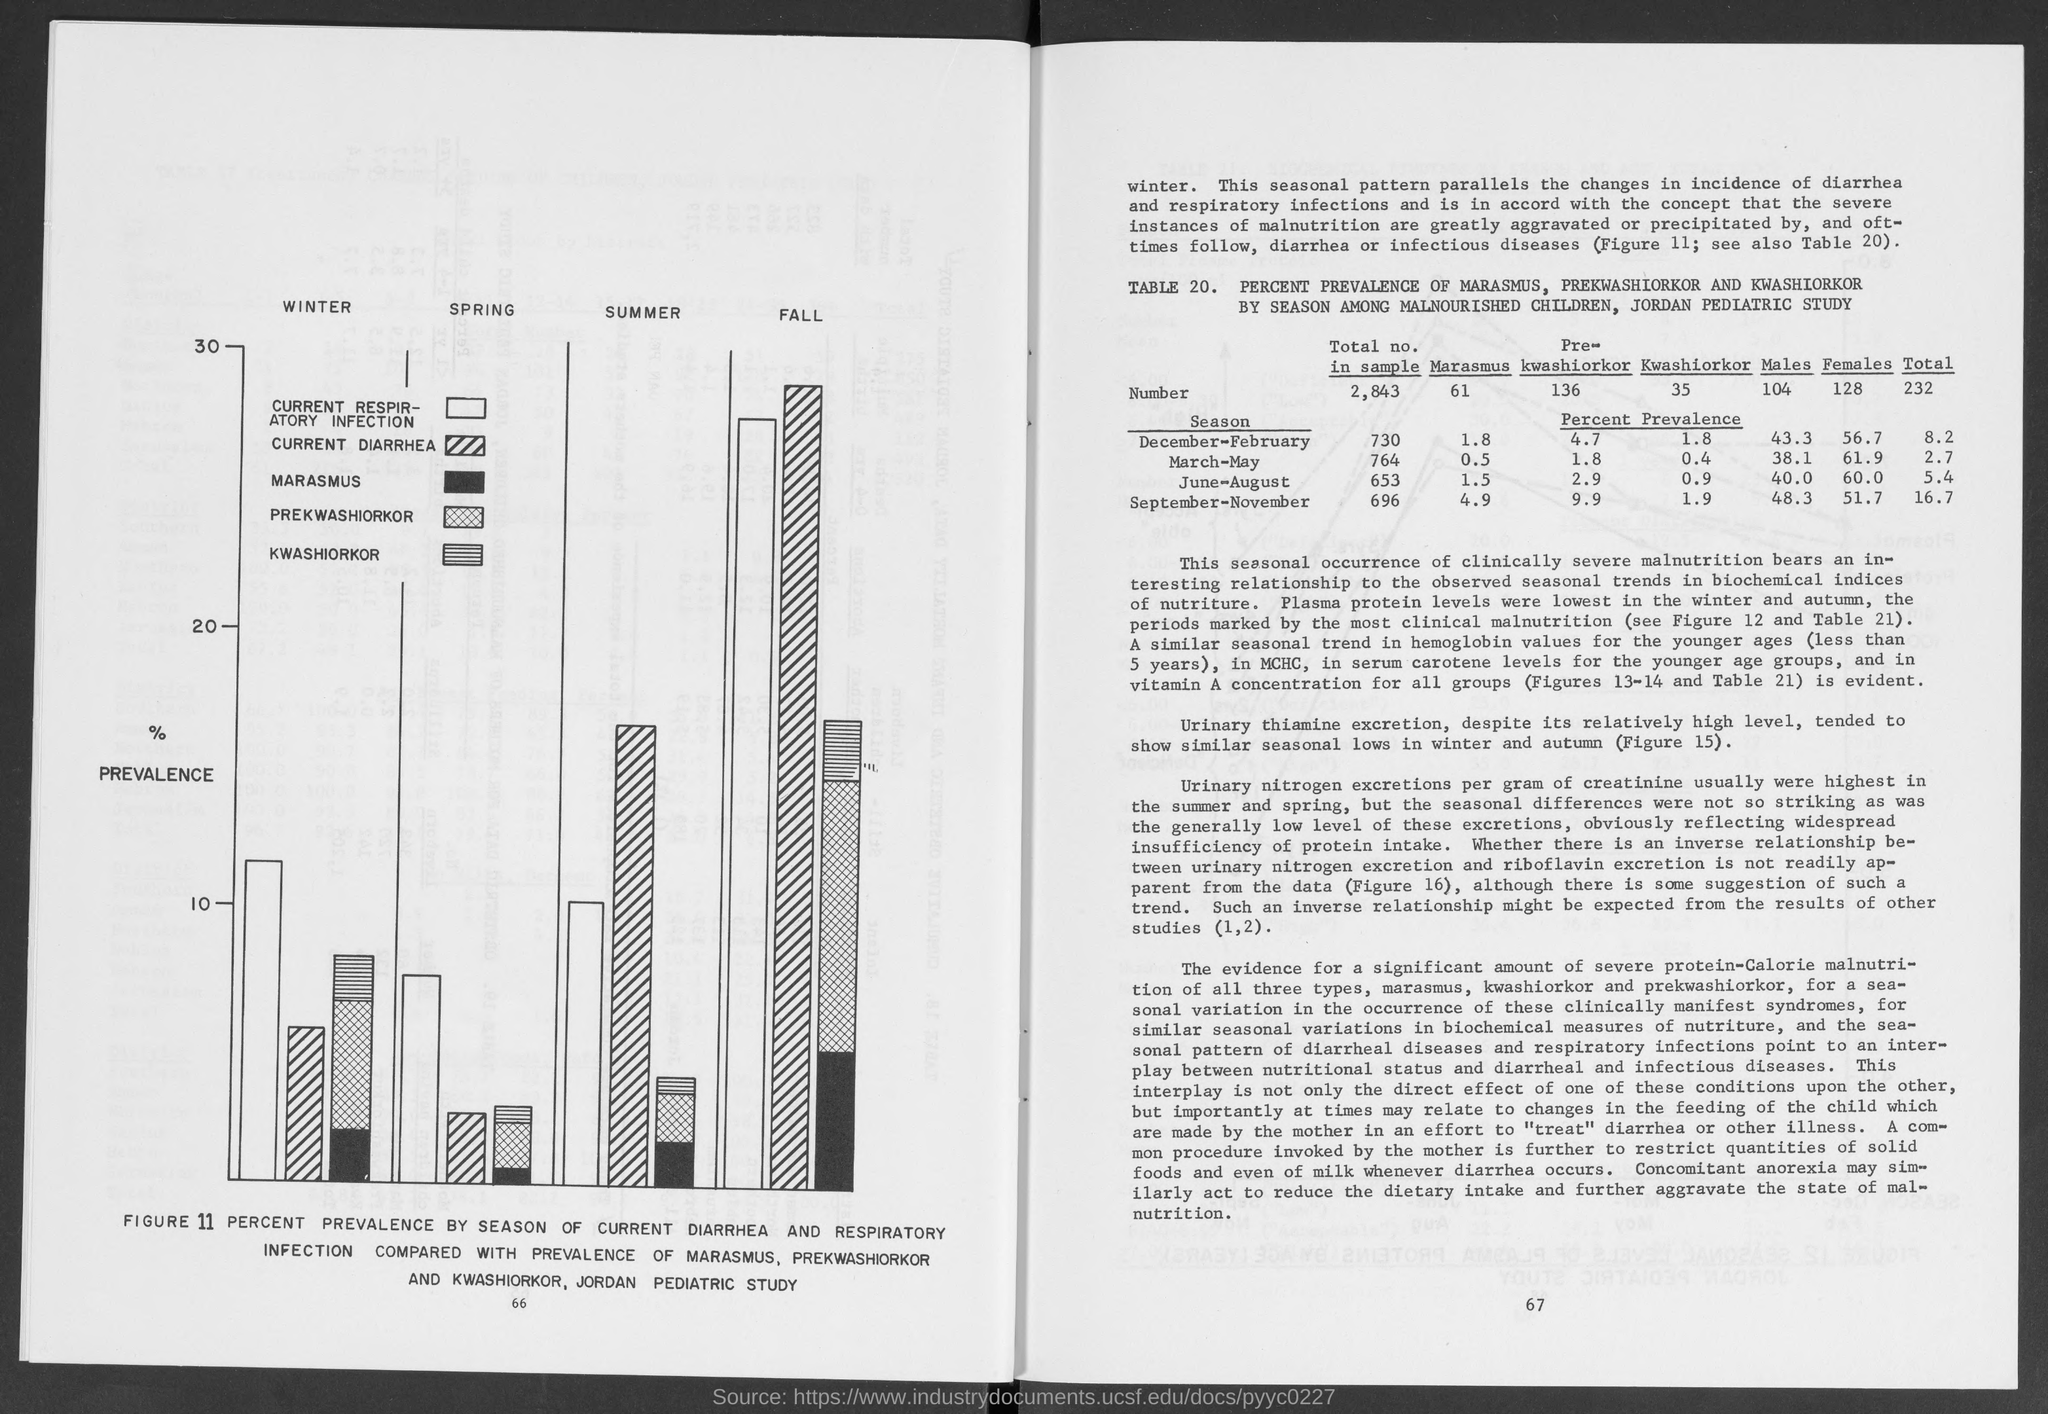What is on the y-axis of the  graph?
Give a very brief answer. % PREVALENCE. "Plasma protein levels were lowest" in which period"?
Ensure brevity in your answer.  Winter and Autumn. What was the"total no. in sample"?
Your response must be concise. 2,843. What was the"Total no. in Marasmus"?
Give a very brief answer. 61. What was the"Total no. in Kwashiorkar"?
Your answer should be very brief. 35. What is the "Percent Prevalence" of "Marasmus"  in "December-February" season?
Ensure brevity in your answer.  1.8. What is the "Percent Prevalence" of "Pre-Kwashiorkar" in "June-August" season?
Ensure brevity in your answer.  2.9. What is the "Percent Prevalence" of "Males" in "June-August" season?
Provide a short and direct response. 40.0. What is the "Percent Prevalence" of "Females" in "September-November" season?
Your answer should be very brief. 51.7. What is the "Percent Prevalence" of "Kwashiorkar" in "September-November" season?
Provide a short and direct response. 1.9. 